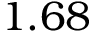<formula> <loc_0><loc_0><loc_500><loc_500>1 . 6 8</formula> 